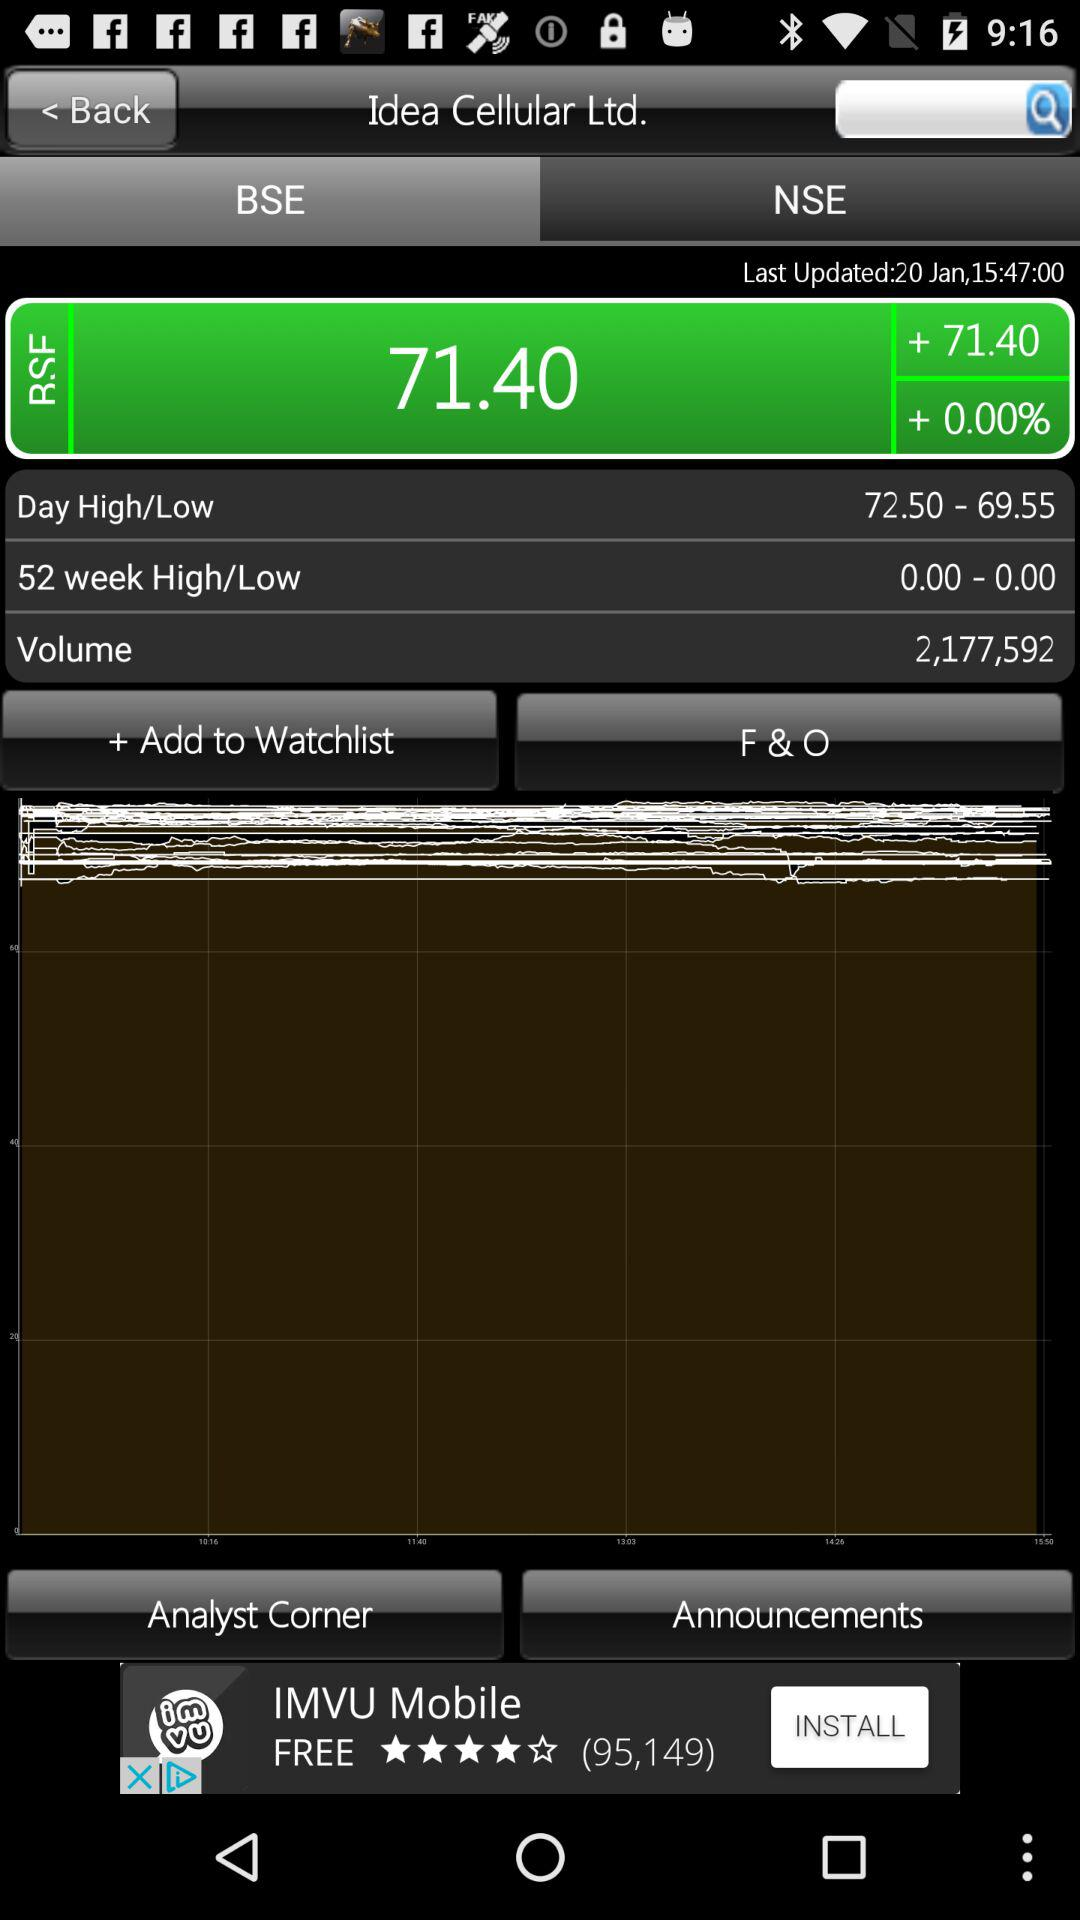What is the time? The time is 15:47:00. 